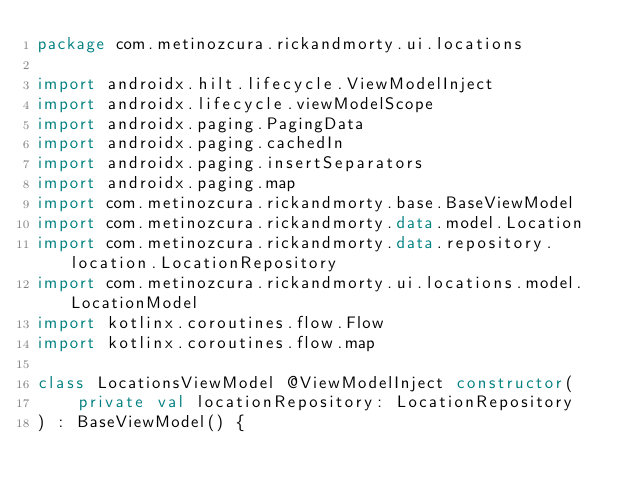Convert code to text. <code><loc_0><loc_0><loc_500><loc_500><_Kotlin_>package com.metinozcura.rickandmorty.ui.locations

import androidx.hilt.lifecycle.ViewModelInject
import androidx.lifecycle.viewModelScope
import androidx.paging.PagingData
import androidx.paging.cachedIn
import androidx.paging.insertSeparators
import androidx.paging.map
import com.metinozcura.rickandmorty.base.BaseViewModel
import com.metinozcura.rickandmorty.data.model.Location
import com.metinozcura.rickandmorty.data.repository.location.LocationRepository
import com.metinozcura.rickandmorty.ui.locations.model.LocationModel
import kotlinx.coroutines.flow.Flow
import kotlinx.coroutines.flow.map

class LocationsViewModel @ViewModelInject constructor(
    private val locationRepository: LocationRepository
) : BaseViewModel() {</code> 